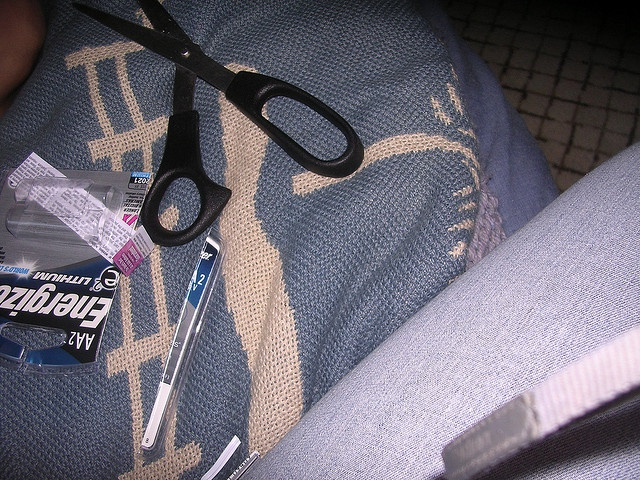Describe the objects in this image and their specific colors. I can see scissors in black, gray, and darkgray tones and people in black and maroon tones in this image. 